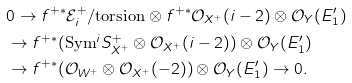Convert formula to latex. <formula><loc_0><loc_0><loc_500><loc_500>& 0 \to f ^ { + * } \mathcal { E } ^ { + } _ { i } / \text {torsion} \otimes f ^ { + * } \mathcal { O } _ { X ^ { + } } ( i - 2 ) \otimes \mathcal { O } _ { Y } ( E ^ { \prime } _ { 1 } ) \\ & \to f ^ { + * } ( \text {Sym} ^ { i } S ^ { + } _ { X ^ { + } } \otimes \mathcal { O } _ { X ^ { + } } ( i - 2 ) ) \otimes \mathcal { O } _ { Y } ( E ^ { \prime } _ { 1 } ) \\ & \to f ^ { + * } ( \mathcal { O } _ { W ^ { + } } \otimes \mathcal { O } _ { X ^ { + } } ( - 2 ) ) \otimes \mathcal { O } _ { Y } ( E ^ { \prime } _ { 1 } ) \to 0 .</formula> 